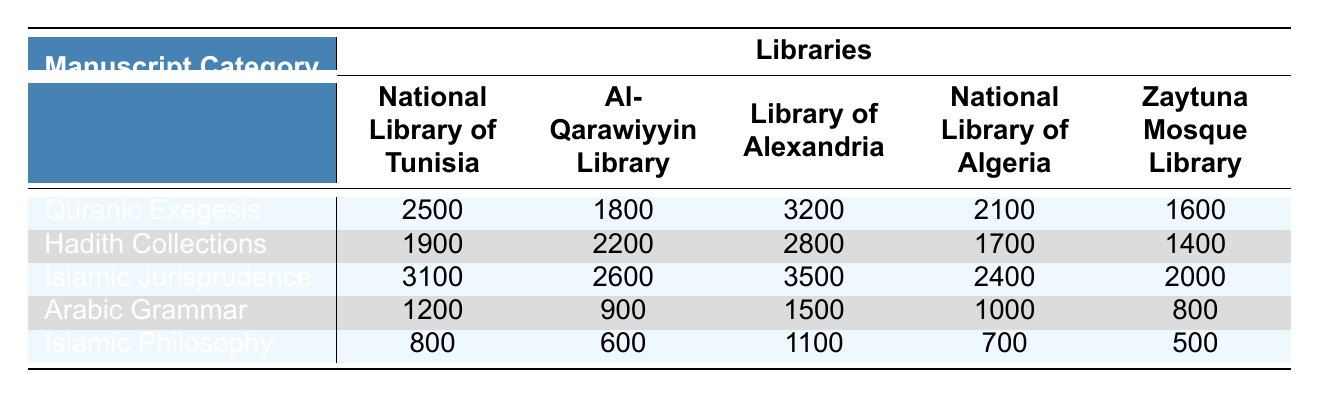What is the highest number of Islamic manuscripts in a single category across all libraries? To find the highest number, we look for the maximum value in the table. In "Islamic Jurisprudence," the Library of Alexandria has 3500 manuscripts, which is more than any other category in any library.
Answer: 3500 Which library contains the most Quranic Exegesis manuscripts? Referring to the row for Quranic Exegesis, the Library of Alexandria has the highest count at 3200 manuscripts compared to the others.
Answer: Library of Alexandria How many Hadith Collections manuscripts does the Zaytuna Mosque Library have? Looking at the Hadith Collections row in the Zaytuna Mosque Library column, we find that it has 1400 manuscripts.
Answer: 1400 What is the total number of Islamic manuscripts in the National Library of Tunisia across all categories? We sum the values in the National Library of Tunisia column: 2500 (Quranic Exegesis) + 1900 (Hadith Collections) + 3100 (Islamic Jurisprudence) + 1200 (Arabic Grammar) + 800 (Islamic Philosophy) = 10200.
Answer: 10200 Which category has fewer manuscripts in the National Library of Algeria than in the National Library of Tunisia? We compare the counts: Quranic Exegesis (2100 vs 2500), Hadith Collections (1700 vs 1900), Arabic Grammar (1000 vs 1200), and Islamic Philosophy (700 vs 800). Only Islamic Jurisprudence (2400 vs 3100) has more. Thus, all except Islamic Jurisprudence have fewer in Algeria.
Answer: Quranic Exegesis, Hadith Collections, Arabic Grammar, Islamic Philosophy What is the average number of manuscripts for the category Islamic Philosophy across all libraries? First, we sum the manuscripts: 800 + 600 + 1100 + 700 + 500 = 3700. Next, we divide by the number of libraries (5) to get 3700 / 5 = 740.
Answer: 740 Which library has the least number of manuscripts in Arabic Grammar? Looking at the Arabic Grammar row, the Zaytuna Mosque Library has the lowest count with 800 manuscripts.
Answer: Zaytuna Mosque Library Is it true that the total number of Hadith Collections manuscripts in the Library of Alexandria is greater than that in the National Library of Algeria? The Library of Alexandria has 2800 manuscripts while the National Library of Algeria has 1700. Since 2800 > 1700, the statement is true.
Answer: Yes If we consider only the libraries with more than 2000 manuscripts in Islamic Jurisprudence, how many libraries meet this criterion? Checking the Islamic Jurisprudence row: National Library of Tunisia (3100), Library of Alexandria (3500), and National Library of Algeria (2400) all surpass 2000 manuscripts, totaling three libraries.
Answer: 3 What is the difference between the highest and lowest number of manuscripts in Arabic Grammar? The maximum is 1200 (National Library of Tunisia) and the minimum is 800 (Zaytuna Mosque Library). The difference is 1200 - 800 = 400.
Answer: 400 